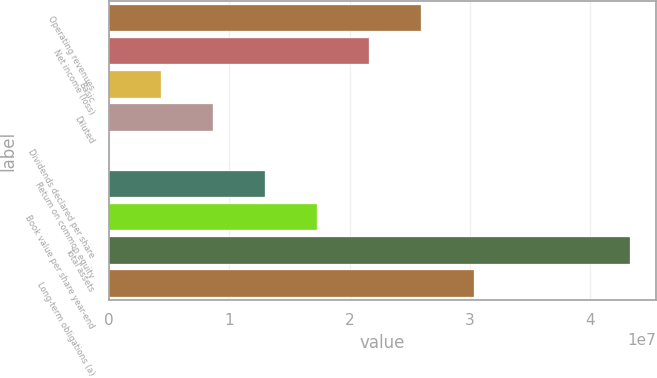<chart> <loc_0><loc_0><loc_500><loc_500><bar_chart><fcel>Operating revenues<fcel>Net income (loss)<fcel>Basic<fcel>Diluted<fcel>Dividends declared per share<fcel>Return on common equity<fcel>Book value per share year-end<fcel>Total assets<fcel>Long-term obligations (a)<nl><fcel>2.59742e+07<fcel>2.16451e+07<fcel>4.32903e+06<fcel>8.65806e+06<fcel>3.32<fcel>1.29871e+07<fcel>1.73161e+07<fcel>4.32903e+07<fcel>3.03032e+07<nl></chart> 